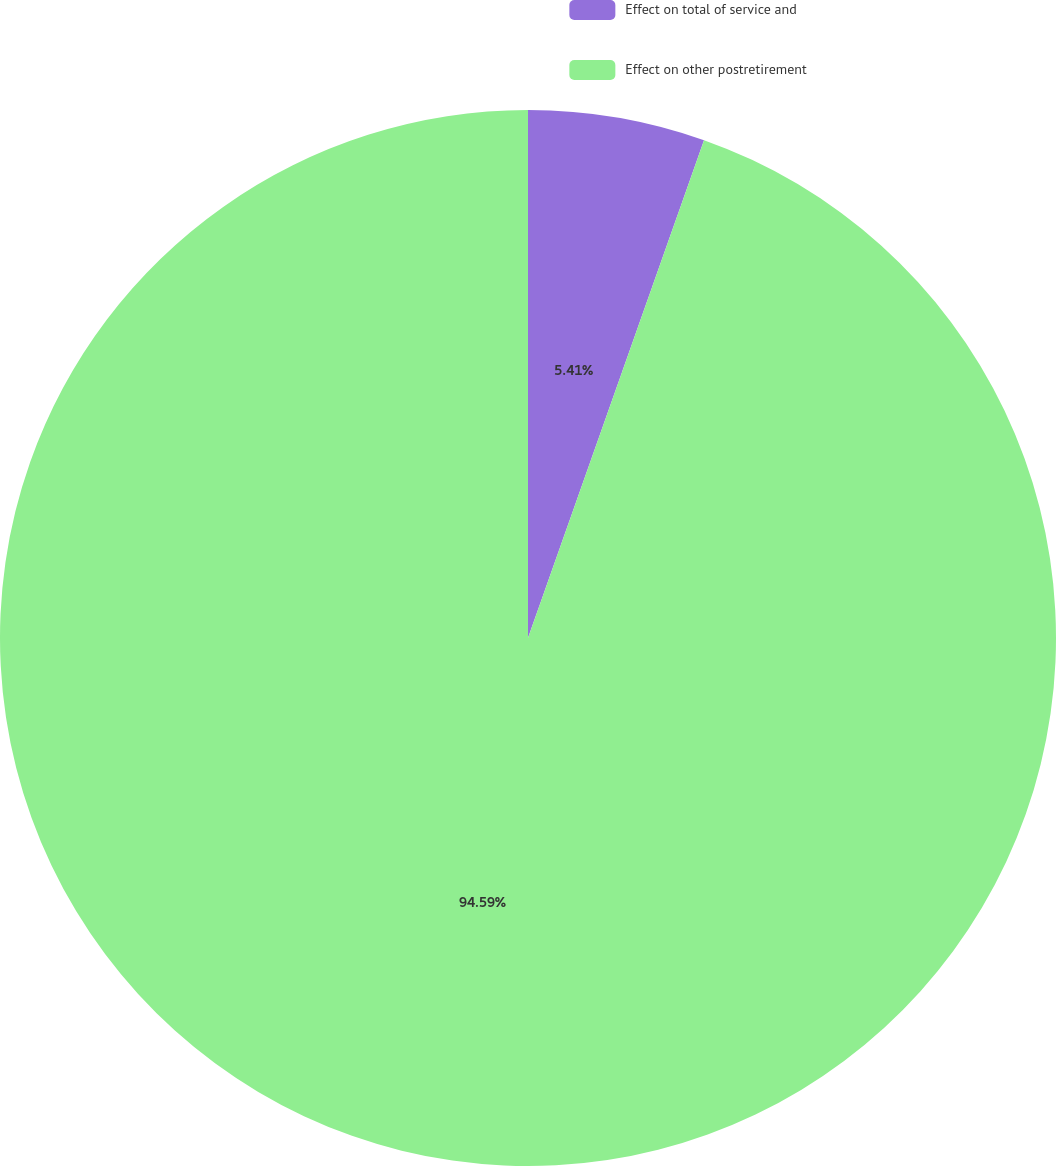Convert chart to OTSL. <chart><loc_0><loc_0><loc_500><loc_500><pie_chart><fcel>Effect on total of service and<fcel>Effect on other postretirement<nl><fcel>5.41%<fcel>94.59%<nl></chart> 